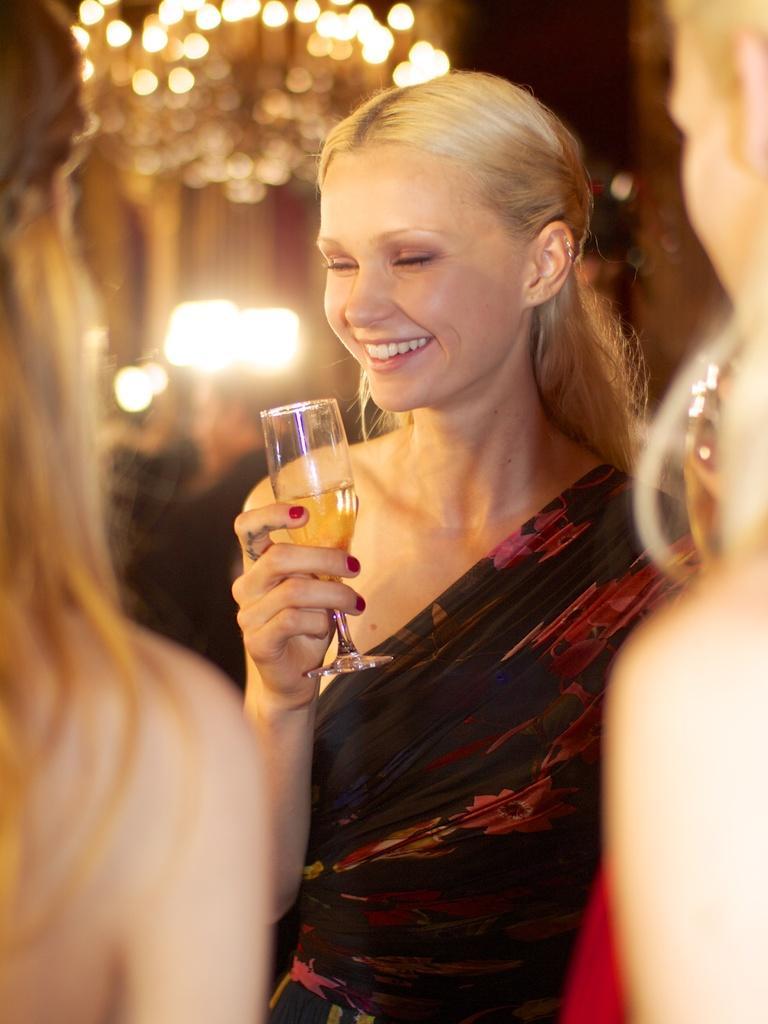Could you give a brief overview of what you see in this image? In this image there are three women at the middle of the image the woman wearing red color dress holding a glass in her hand. 